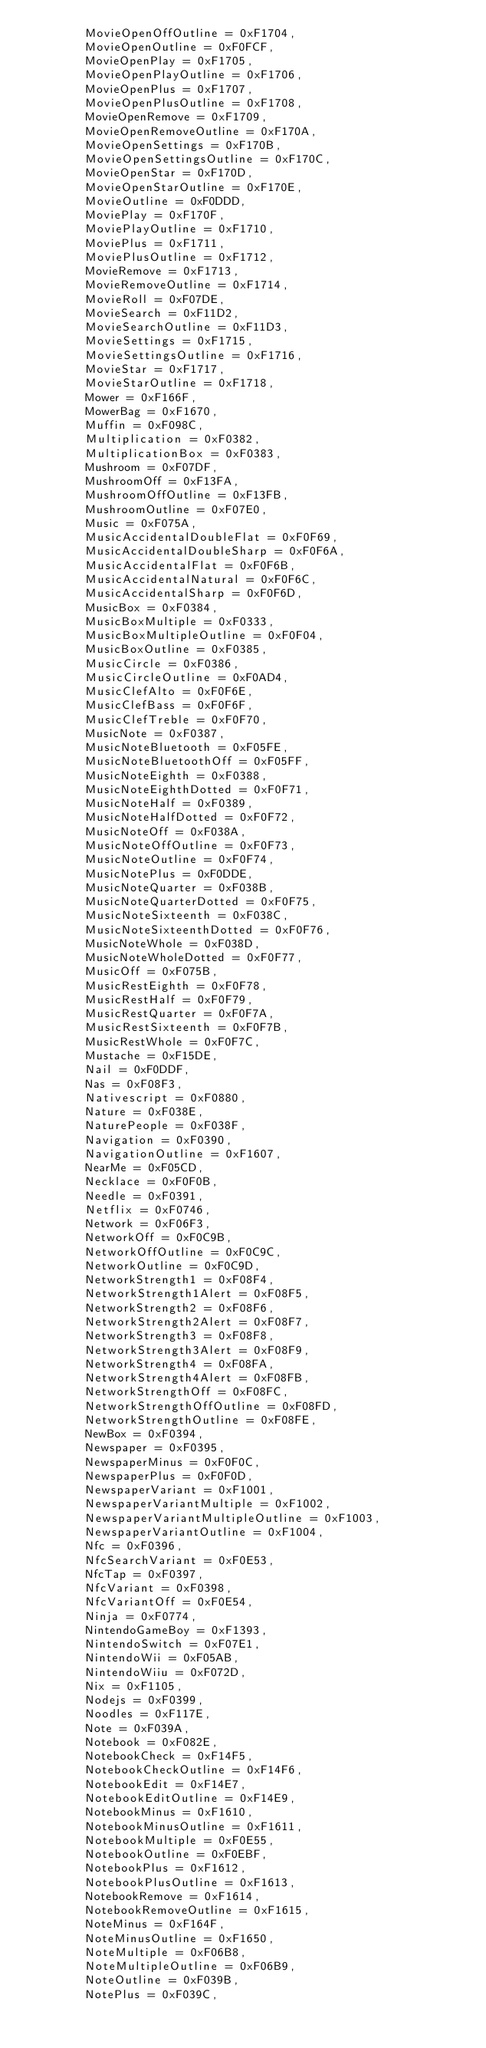<code> <loc_0><loc_0><loc_500><loc_500><_C#_>        MovieOpenOffOutline = 0xF1704,
        MovieOpenOutline = 0xF0FCF,
        MovieOpenPlay = 0xF1705,
        MovieOpenPlayOutline = 0xF1706,
        MovieOpenPlus = 0xF1707,
        MovieOpenPlusOutline = 0xF1708,
        MovieOpenRemove = 0xF1709,
        MovieOpenRemoveOutline = 0xF170A,
        MovieOpenSettings = 0xF170B,
        MovieOpenSettingsOutline = 0xF170C,
        MovieOpenStar = 0xF170D,
        MovieOpenStarOutline = 0xF170E,
        MovieOutline = 0xF0DDD,
        MoviePlay = 0xF170F,
        MoviePlayOutline = 0xF1710,
        MoviePlus = 0xF1711,
        MoviePlusOutline = 0xF1712,
        MovieRemove = 0xF1713,
        MovieRemoveOutline = 0xF1714,
        MovieRoll = 0xF07DE,
        MovieSearch = 0xF11D2,
        MovieSearchOutline = 0xF11D3,
        MovieSettings = 0xF1715,
        MovieSettingsOutline = 0xF1716,
        MovieStar = 0xF1717,
        MovieStarOutline = 0xF1718,
        Mower = 0xF166F,
        MowerBag = 0xF1670,
        Muffin = 0xF098C,
        Multiplication = 0xF0382,
        MultiplicationBox = 0xF0383,
        Mushroom = 0xF07DF,
        MushroomOff = 0xF13FA,
        MushroomOffOutline = 0xF13FB,
        MushroomOutline = 0xF07E0,
        Music = 0xF075A,
        MusicAccidentalDoubleFlat = 0xF0F69,
        MusicAccidentalDoubleSharp = 0xF0F6A,
        MusicAccidentalFlat = 0xF0F6B,
        MusicAccidentalNatural = 0xF0F6C,
        MusicAccidentalSharp = 0xF0F6D,
        MusicBox = 0xF0384,
        MusicBoxMultiple = 0xF0333,
        MusicBoxMultipleOutline = 0xF0F04,
        MusicBoxOutline = 0xF0385,
        MusicCircle = 0xF0386,
        MusicCircleOutline = 0xF0AD4,
        MusicClefAlto = 0xF0F6E,
        MusicClefBass = 0xF0F6F,
        MusicClefTreble = 0xF0F70,
        MusicNote = 0xF0387,
        MusicNoteBluetooth = 0xF05FE,
        MusicNoteBluetoothOff = 0xF05FF,
        MusicNoteEighth = 0xF0388,
        MusicNoteEighthDotted = 0xF0F71,
        MusicNoteHalf = 0xF0389,
        MusicNoteHalfDotted = 0xF0F72,
        MusicNoteOff = 0xF038A,
        MusicNoteOffOutline = 0xF0F73,
        MusicNoteOutline = 0xF0F74,
        MusicNotePlus = 0xF0DDE,
        MusicNoteQuarter = 0xF038B,
        MusicNoteQuarterDotted = 0xF0F75,
        MusicNoteSixteenth = 0xF038C,
        MusicNoteSixteenthDotted = 0xF0F76,
        MusicNoteWhole = 0xF038D,
        MusicNoteWholeDotted = 0xF0F77,
        MusicOff = 0xF075B,
        MusicRestEighth = 0xF0F78,
        MusicRestHalf = 0xF0F79,
        MusicRestQuarter = 0xF0F7A,
        MusicRestSixteenth = 0xF0F7B,
        MusicRestWhole = 0xF0F7C,
        Mustache = 0xF15DE,
        Nail = 0xF0DDF,
        Nas = 0xF08F3,
        Nativescript = 0xF0880,
        Nature = 0xF038E,
        NaturePeople = 0xF038F,
        Navigation = 0xF0390,
        NavigationOutline = 0xF1607,
        NearMe = 0xF05CD,
        Necklace = 0xF0F0B,
        Needle = 0xF0391,
        Netflix = 0xF0746,
        Network = 0xF06F3,
        NetworkOff = 0xF0C9B,
        NetworkOffOutline = 0xF0C9C,
        NetworkOutline = 0xF0C9D,
        NetworkStrength1 = 0xF08F4,
        NetworkStrength1Alert = 0xF08F5,
        NetworkStrength2 = 0xF08F6,
        NetworkStrength2Alert = 0xF08F7,
        NetworkStrength3 = 0xF08F8,
        NetworkStrength3Alert = 0xF08F9,
        NetworkStrength4 = 0xF08FA,
        NetworkStrength4Alert = 0xF08FB,
        NetworkStrengthOff = 0xF08FC,
        NetworkStrengthOffOutline = 0xF08FD,
        NetworkStrengthOutline = 0xF08FE,
        NewBox = 0xF0394,
        Newspaper = 0xF0395,
        NewspaperMinus = 0xF0F0C,
        NewspaperPlus = 0xF0F0D,
        NewspaperVariant = 0xF1001,
        NewspaperVariantMultiple = 0xF1002,
        NewspaperVariantMultipleOutline = 0xF1003,
        NewspaperVariantOutline = 0xF1004,
        Nfc = 0xF0396,
        NfcSearchVariant = 0xF0E53,
        NfcTap = 0xF0397,
        NfcVariant = 0xF0398,
        NfcVariantOff = 0xF0E54,
        Ninja = 0xF0774,
        NintendoGameBoy = 0xF1393,
        NintendoSwitch = 0xF07E1,
        NintendoWii = 0xF05AB,
        NintendoWiiu = 0xF072D,
        Nix = 0xF1105,
        Nodejs = 0xF0399,
        Noodles = 0xF117E,
        Note = 0xF039A,
        Notebook = 0xF082E,
        NotebookCheck = 0xF14F5,
        NotebookCheckOutline = 0xF14F6,
        NotebookEdit = 0xF14E7,
        NotebookEditOutline = 0xF14E9,
        NotebookMinus = 0xF1610,
        NotebookMinusOutline = 0xF1611,
        NotebookMultiple = 0xF0E55,
        NotebookOutline = 0xF0EBF,
        NotebookPlus = 0xF1612,
        NotebookPlusOutline = 0xF1613,
        NotebookRemove = 0xF1614,
        NotebookRemoveOutline = 0xF1615,
        NoteMinus = 0xF164F,
        NoteMinusOutline = 0xF1650,
        NoteMultiple = 0xF06B8,
        NoteMultipleOutline = 0xF06B9,
        NoteOutline = 0xF039B,
        NotePlus = 0xF039C,</code> 